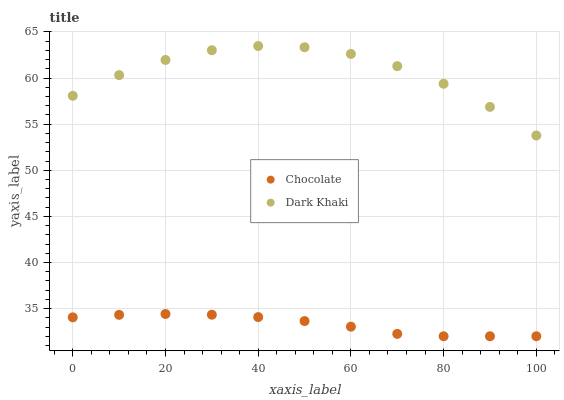Does Chocolate have the minimum area under the curve?
Answer yes or no. Yes. Does Dark Khaki have the maximum area under the curve?
Answer yes or no. Yes. Does Chocolate have the maximum area under the curve?
Answer yes or no. No. Is Chocolate the smoothest?
Answer yes or no. Yes. Is Dark Khaki the roughest?
Answer yes or no. Yes. Is Chocolate the roughest?
Answer yes or no. No. Does Chocolate have the lowest value?
Answer yes or no. Yes. Does Dark Khaki have the highest value?
Answer yes or no. Yes. Does Chocolate have the highest value?
Answer yes or no. No. Is Chocolate less than Dark Khaki?
Answer yes or no. Yes. Is Dark Khaki greater than Chocolate?
Answer yes or no. Yes. Does Chocolate intersect Dark Khaki?
Answer yes or no. No. 